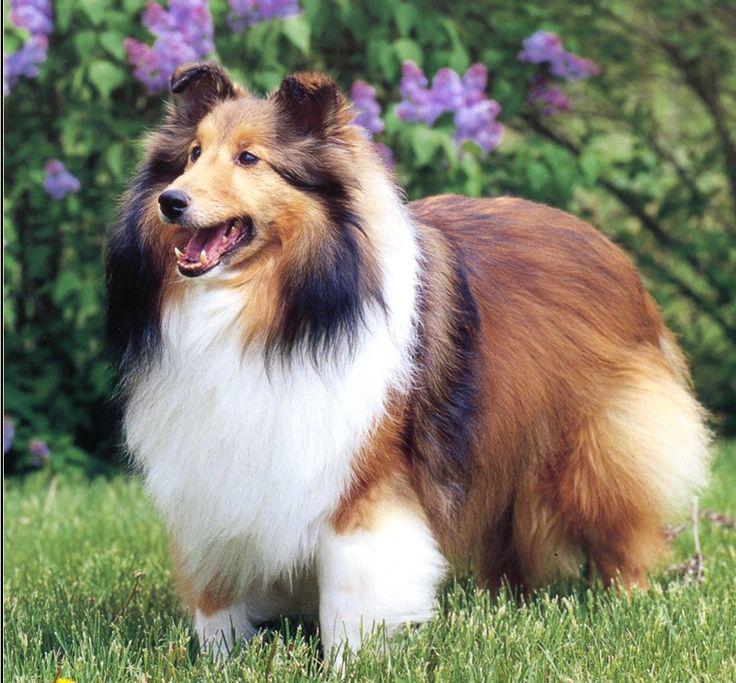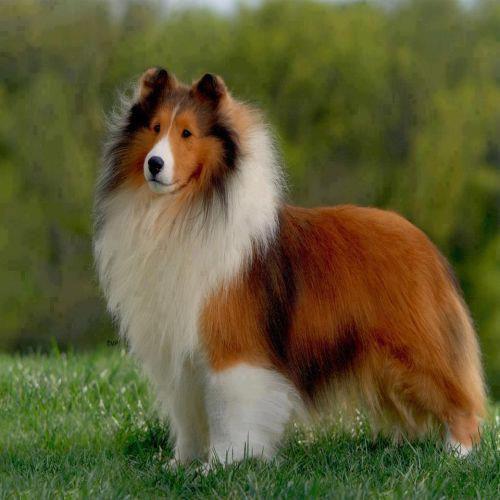The first image is the image on the left, the second image is the image on the right. Analyze the images presented: Is the assertion "In 1 of the images, 1 dog has an open mouth." valid? Answer yes or no. Yes. 